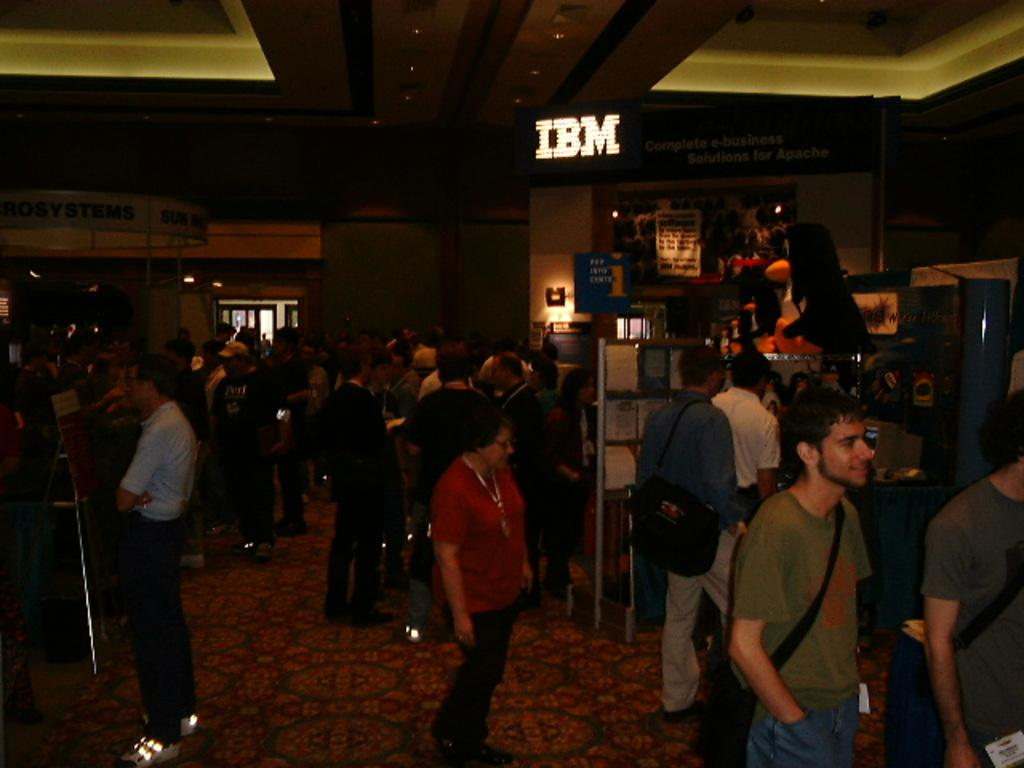How many people are in the image? There are multiple persons in the image. What are the people in the image doing? Some of the persons are standing, while others are walking. What can be seen in the background of the image? There are boards with text and lights visible in the background. Is there any architectural feature in the background? Yes, there is a window in the background. What type of attention is the school giving to the land in the image? There is no school or land present in the image, so it is not possible to determine what type of attention might be given. 